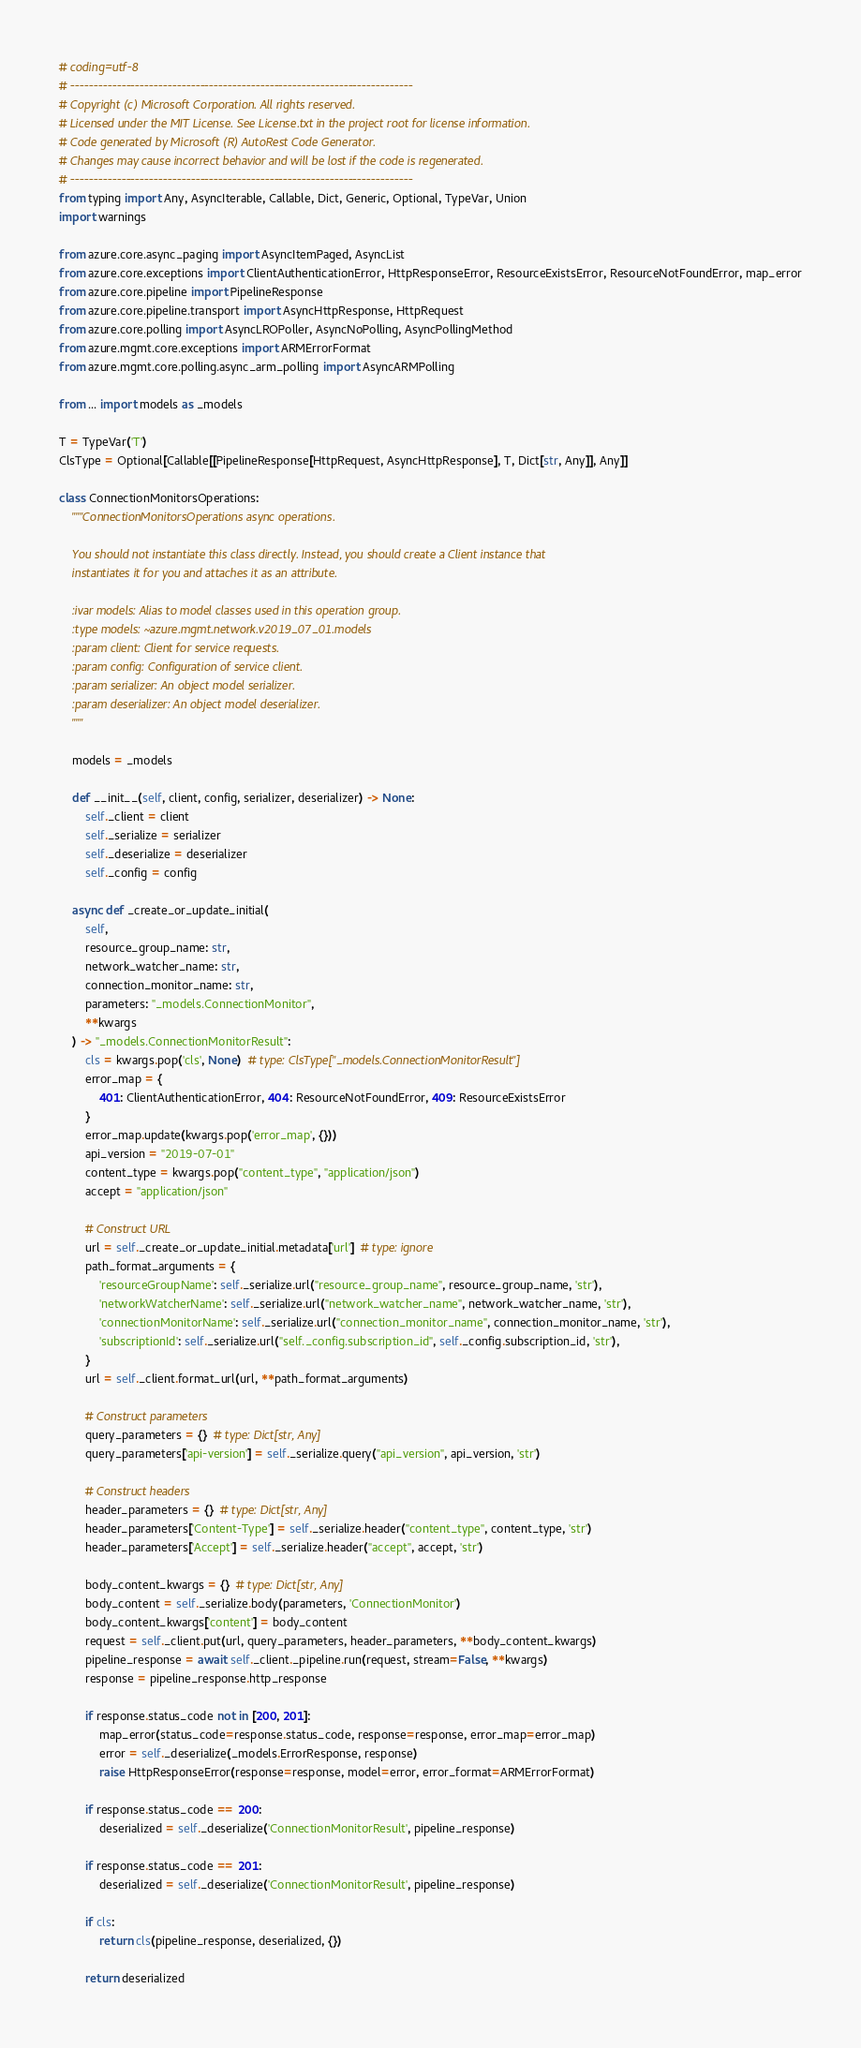<code> <loc_0><loc_0><loc_500><loc_500><_Python_># coding=utf-8
# --------------------------------------------------------------------------
# Copyright (c) Microsoft Corporation. All rights reserved.
# Licensed under the MIT License. See License.txt in the project root for license information.
# Code generated by Microsoft (R) AutoRest Code Generator.
# Changes may cause incorrect behavior and will be lost if the code is regenerated.
# --------------------------------------------------------------------------
from typing import Any, AsyncIterable, Callable, Dict, Generic, Optional, TypeVar, Union
import warnings

from azure.core.async_paging import AsyncItemPaged, AsyncList
from azure.core.exceptions import ClientAuthenticationError, HttpResponseError, ResourceExistsError, ResourceNotFoundError, map_error
from azure.core.pipeline import PipelineResponse
from azure.core.pipeline.transport import AsyncHttpResponse, HttpRequest
from azure.core.polling import AsyncLROPoller, AsyncNoPolling, AsyncPollingMethod
from azure.mgmt.core.exceptions import ARMErrorFormat
from azure.mgmt.core.polling.async_arm_polling import AsyncARMPolling

from ... import models as _models

T = TypeVar('T')
ClsType = Optional[Callable[[PipelineResponse[HttpRequest, AsyncHttpResponse], T, Dict[str, Any]], Any]]

class ConnectionMonitorsOperations:
    """ConnectionMonitorsOperations async operations.

    You should not instantiate this class directly. Instead, you should create a Client instance that
    instantiates it for you and attaches it as an attribute.

    :ivar models: Alias to model classes used in this operation group.
    :type models: ~azure.mgmt.network.v2019_07_01.models
    :param client: Client for service requests.
    :param config: Configuration of service client.
    :param serializer: An object model serializer.
    :param deserializer: An object model deserializer.
    """

    models = _models

    def __init__(self, client, config, serializer, deserializer) -> None:
        self._client = client
        self._serialize = serializer
        self._deserialize = deserializer
        self._config = config

    async def _create_or_update_initial(
        self,
        resource_group_name: str,
        network_watcher_name: str,
        connection_monitor_name: str,
        parameters: "_models.ConnectionMonitor",
        **kwargs
    ) -> "_models.ConnectionMonitorResult":
        cls = kwargs.pop('cls', None)  # type: ClsType["_models.ConnectionMonitorResult"]
        error_map = {
            401: ClientAuthenticationError, 404: ResourceNotFoundError, 409: ResourceExistsError
        }
        error_map.update(kwargs.pop('error_map', {}))
        api_version = "2019-07-01"
        content_type = kwargs.pop("content_type", "application/json")
        accept = "application/json"

        # Construct URL
        url = self._create_or_update_initial.metadata['url']  # type: ignore
        path_format_arguments = {
            'resourceGroupName': self._serialize.url("resource_group_name", resource_group_name, 'str'),
            'networkWatcherName': self._serialize.url("network_watcher_name", network_watcher_name, 'str'),
            'connectionMonitorName': self._serialize.url("connection_monitor_name", connection_monitor_name, 'str'),
            'subscriptionId': self._serialize.url("self._config.subscription_id", self._config.subscription_id, 'str'),
        }
        url = self._client.format_url(url, **path_format_arguments)

        # Construct parameters
        query_parameters = {}  # type: Dict[str, Any]
        query_parameters['api-version'] = self._serialize.query("api_version", api_version, 'str')

        # Construct headers
        header_parameters = {}  # type: Dict[str, Any]
        header_parameters['Content-Type'] = self._serialize.header("content_type", content_type, 'str')
        header_parameters['Accept'] = self._serialize.header("accept", accept, 'str')

        body_content_kwargs = {}  # type: Dict[str, Any]
        body_content = self._serialize.body(parameters, 'ConnectionMonitor')
        body_content_kwargs['content'] = body_content
        request = self._client.put(url, query_parameters, header_parameters, **body_content_kwargs)
        pipeline_response = await self._client._pipeline.run(request, stream=False, **kwargs)
        response = pipeline_response.http_response

        if response.status_code not in [200, 201]:
            map_error(status_code=response.status_code, response=response, error_map=error_map)
            error = self._deserialize(_models.ErrorResponse, response)
            raise HttpResponseError(response=response, model=error, error_format=ARMErrorFormat)

        if response.status_code == 200:
            deserialized = self._deserialize('ConnectionMonitorResult', pipeline_response)

        if response.status_code == 201:
            deserialized = self._deserialize('ConnectionMonitorResult', pipeline_response)

        if cls:
            return cls(pipeline_response, deserialized, {})

        return deserialized</code> 